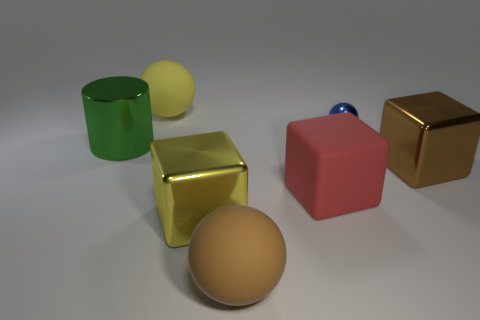Add 3 yellow metallic blocks. How many objects exist? 10 Subtract all cylinders. How many objects are left? 6 Subtract 0 gray cubes. How many objects are left? 7 Subtract all small spheres. Subtract all small shiny objects. How many objects are left? 5 Add 7 blue metal things. How many blue metal things are left? 8 Add 1 small blue things. How many small blue things exist? 2 